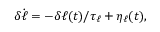Convert formula to latex. <formula><loc_0><loc_0><loc_500><loc_500>\delta \dot { \ell } = - \delta \ell ( t ) / \tau _ { \ell } + \eta _ { \ell } ( t ) ,</formula> 